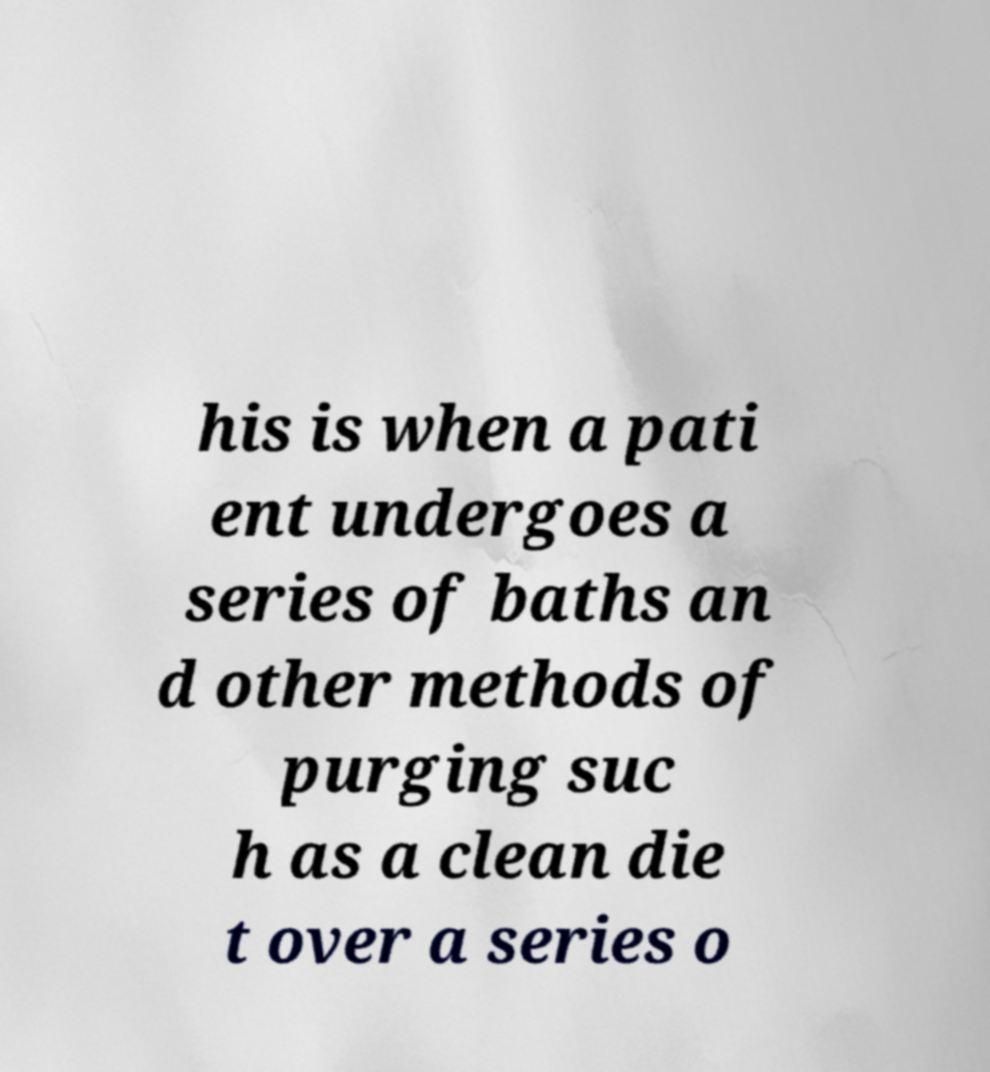Can you read and provide the text displayed in the image?This photo seems to have some interesting text. Can you extract and type it out for me? his is when a pati ent undergoes a series of baths an d other methods of purging suc h as a clean die t over a series o 